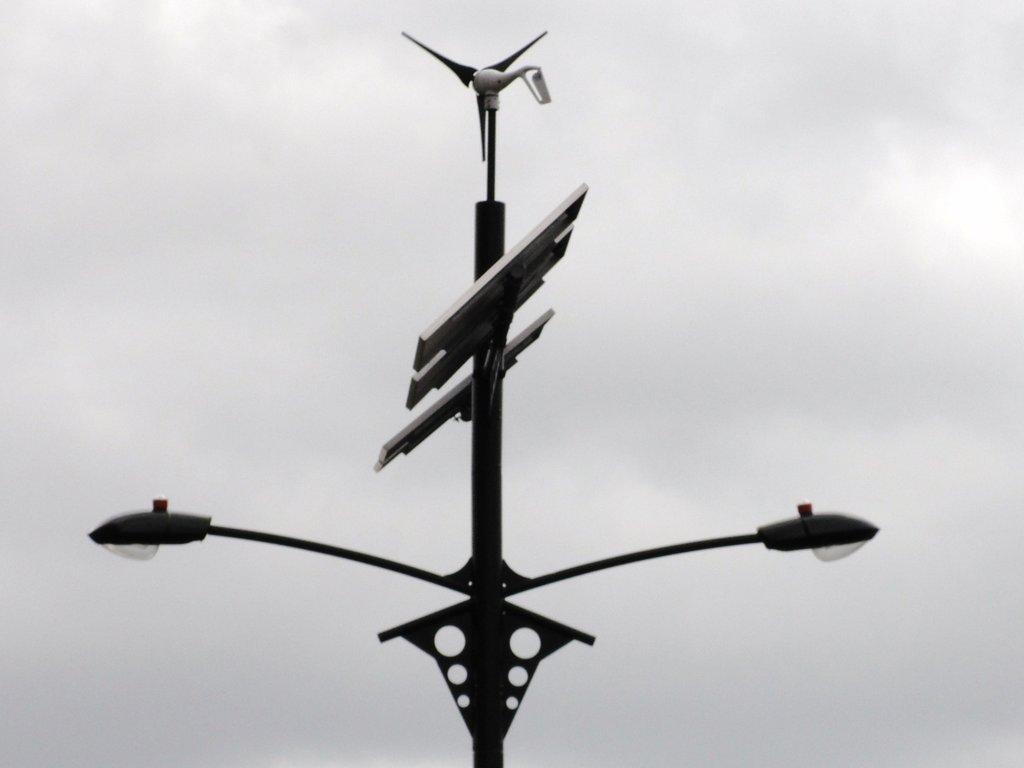What is the main object in the image? There is a pole in the image. What is attached to the pole? Two lights and some boards are attached to the pole. What can be seen in the background of the image? The sky is visible in the background of the image. What type of fruit is hanging from the pole in the image? There is no fruit hanging from the pole in the image. How many boys are climbing the pole in the image? There are no boys present in the image; it only features a pole with lights and boards. 